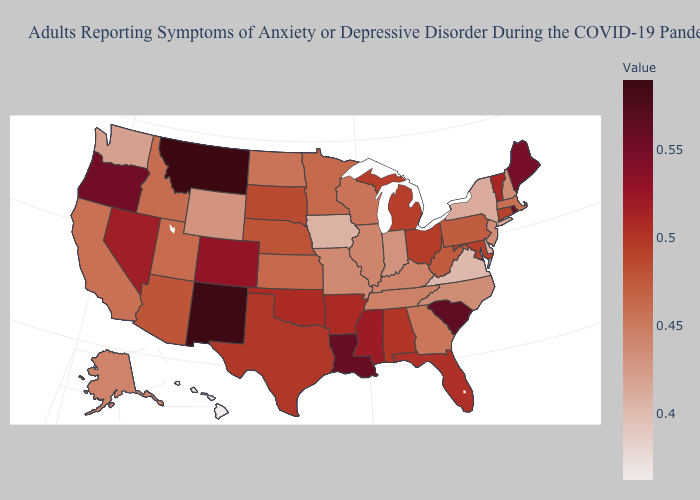Which states have the lowest value in the MidWest?
Quick response, please. Iowa. Does North Dakota have the lowest value in the USA?
Keep it brief. No. Among the states that border Idaho , does Montana have the lowest value?
Concise answer only. No. Among the states that border Colorado , which have the highest value?
Short answer required. New Mexico. Among the states that border Wyoming , which have the lowest value?
Answer briefly. Idaho. Which states have the lowest value in the USA?
Short answer required. Hawaii. 